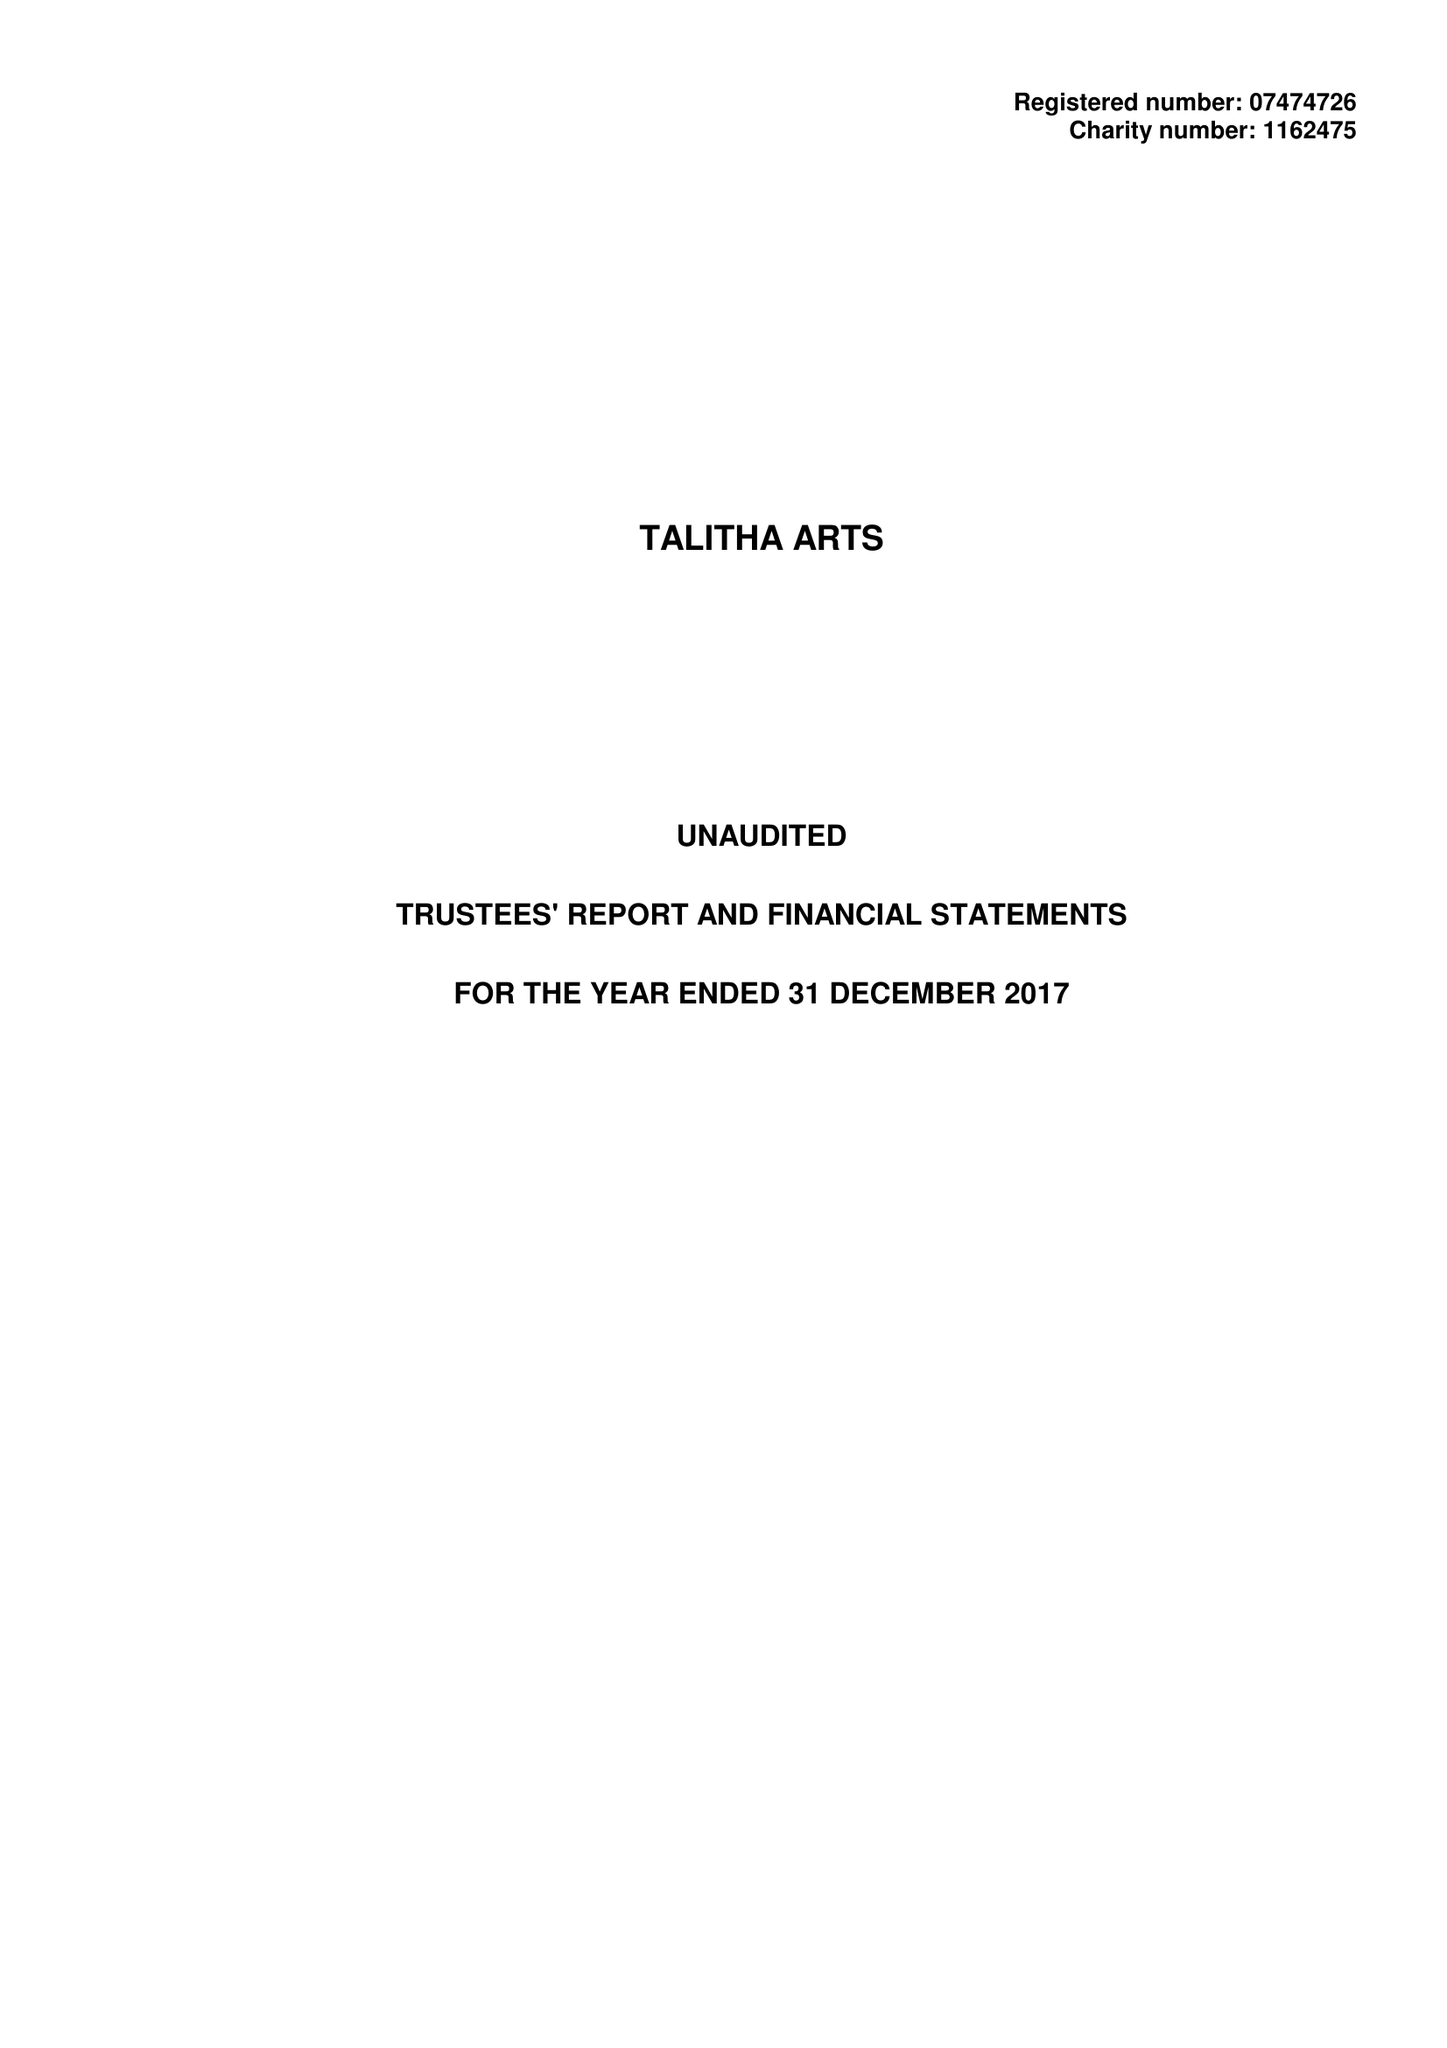What is the value for the charity_number?
Answer the question using a single word or phrase. 1162475 